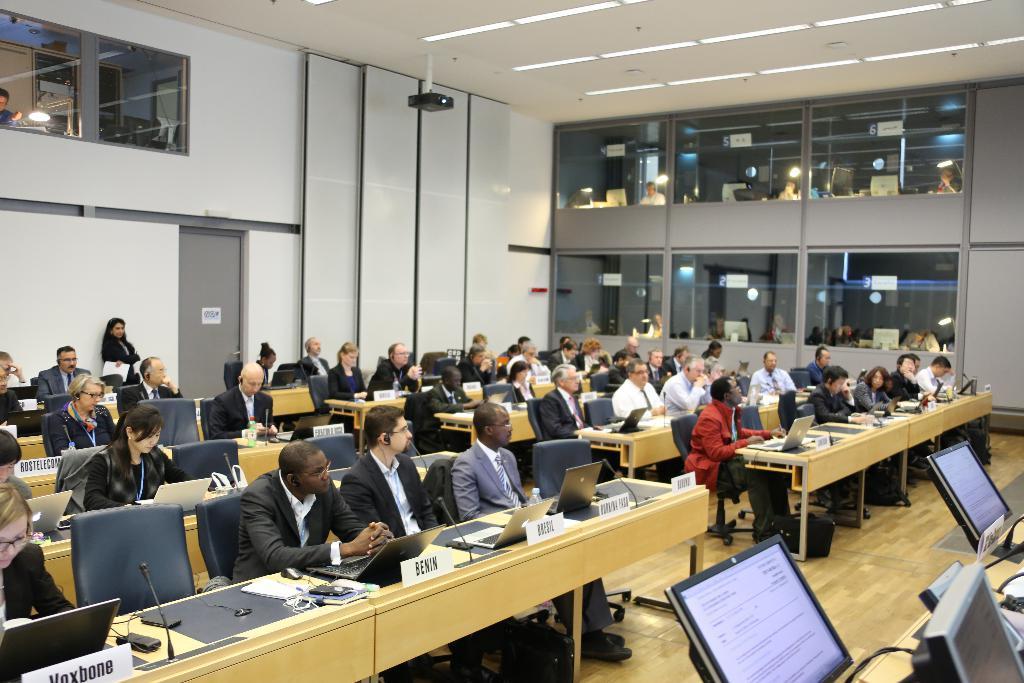In one or two sentences, can you explain what this image depicts? In this picture we can see all the persons sitting on chairs in front of a table and on the table we can see name boards, mikes, laptops. This is adoor. These are windows and light. This is a projector. This is a floor. We can see few screens here. We can see one woman is standing holding a paper in her hand. 